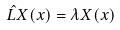Convert formula to latex. <formula><loc_0><loc_0><loc_500><loc_500>\hat { L } X ( x ) = \lambda X ( x )</formula> 